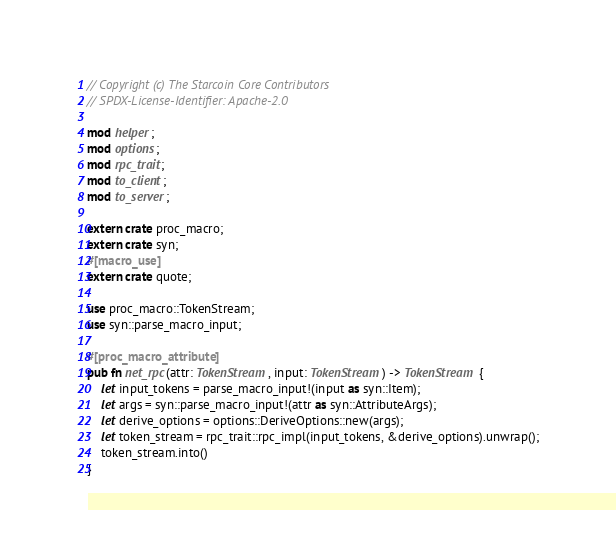<code> <loc_0><loc_0><loc_500><loc_500><_Rust_>// Copyright (c) The Starcoin Core Contributors
// SPDX-License-Identifier: Apache-2.0

mod helper;
mod options;
mod rpc_trait;
mod to_client;
mod to_server;

extern crate proc_macro;
extern crate syn;
#[macro_use]
extern crate quote;

use proc_macro::TokenStream;
use syn::parse_macro_input;

#[proc_macro_attribute]
pub fn net_rpc(attr: TokenStream, input: TokenStream) -> TokenStream {
    let input_tokens = parse_macro_input!(input as syn::Item);
    let args = syn::parse_macro_input!(attr as syn::AttributeArgs);
    let derive_options = options::DeriveOptions::new(args);
    let token_stream = rpc_trait::rpc_impl(input_tokens, &derive_options).unwrap();
    token_stream.into()
}
</code> 